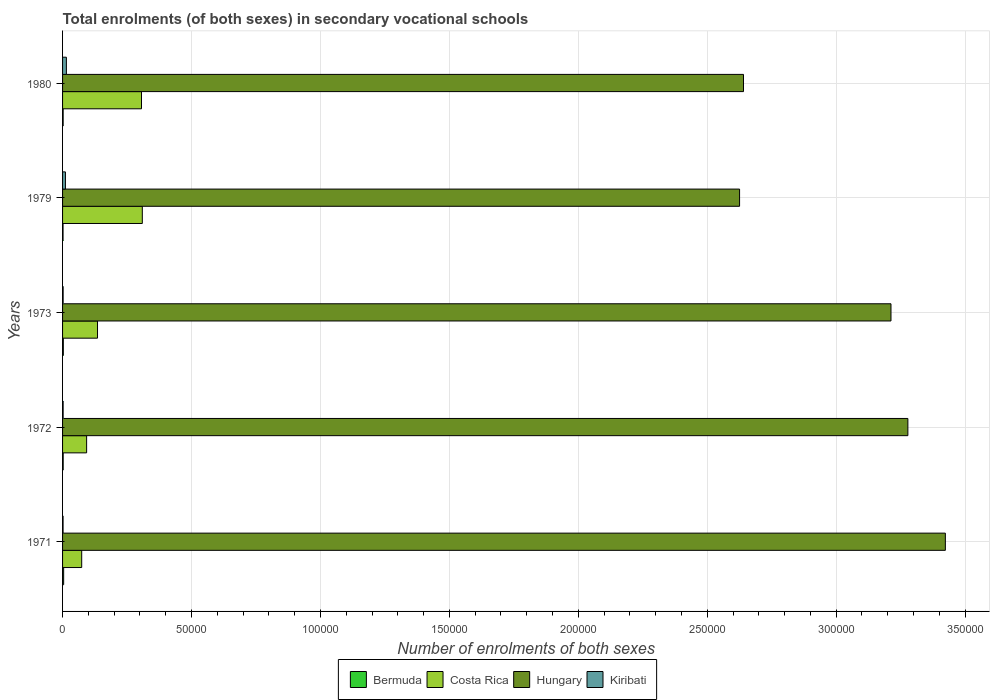Are the number of bars per tick equal to the number of legend labels?
Make the answer very short. Yes. How many bars are there on the 1st tick from the top?
Offer a very short reply. 4. What is the label of the 4th group of bars from the top?
Provide a succinct answer. 1972. What is the number of enrolments in secondary schools in Bermuda in 1979?
Provide a short and direct response. 184. Across all years, what is the maximum number of enrolments in secondary schools in Kiribati?
Provide a succinct answer. 1483. Across all years, what is the minimum number of enrolments in secondary schools in Costa Rica?
Offer a very short reply. 7424. In which year was the number of enrolments in secondary schools in Hungary minimum?
Provide a succinct answer. 1979. What is the total number of enrolments in secondary schools in Kiribati in the graph?
Ensure brevity in your answer.  3242. What is the difference between the number of enrolments in secondary schools in Bermuda in 1971 and that in 1979?
Provide a succinct answer. 240. What is the difference between the number of enrolments in secondary schools in Hungary in 1971 and the number of enrolments in secondary schools in Bermuda in 1980?
Your answer should be very brief. 3.42e+05. What is the average number of enrolments in secondary schools in Hungary per year?
Make the answer very short. 3.04e+05. In the year 1980, what is the difference between the number of enrolments in secondary schools in Kiribati and number of enrolments in secondary schools in Bermuda?
Your answer should be compact. 1256. In how many years, is the number of enrolments in secondary schools in Costa Rica greater than 150000 ?
Offer a terse response. 0. What is the ratio of the number of enrolments in secondary schools in Costa Rica in 1971 to that in 1980?
Offer a very short reply. 0.24. Is the number of enrolments in secondary schools in Bermuda in 1972 less than that in 1979?
Provide a short and direct response. No. Is the difference between the number of enrolments in secondary schools in Kiribati in 1971 and 1980 greater than the difference between the number of enrolments in secondary schools in Bermuda in 1971 and 1980?
Provide a succinct answer. No. What is the difference between the highest and the second highest number of enrolments in secondary schools in Costa Rica?
Provide a short and direct response. 313. What is the difference between the highest and the lowest number of enrolments in secondary schools in Hungary?
Provide a succinct answer. 7.98e+04. Is the sum of the number of enrolments in secondary schools in Kiribati in 1973 and 1980 greater than the maximum number of enrolments in secondary schools in Hungary across all years?
Your answer should be very brief. No. Is it the case that in every year, the sum of the number of enrolments in secondary schools in Hungary and number of enrolments in secondary schools in Kiribati is greater than the sum of number of enrolments in secondary schools in Costa Rica and number of enrolments in secondary schools in Bermuda?
Your response must be concise. Yes. What does the 1st bar from the top in 1971 represents?
Offer a terse response. Kiribati. What does the 4th bar from the bottom in 1980 represents?
Ensure brevity in your answer.  Kiribati. Are all the bars in the graph horizontal?
Ensure brevity in your answer.  Yes. What is the difference between two consecutive major ticks on the X-axis?
Your answer should be compact. 5.00e+04. Are the values on the major ticks of X-axis written in scientific E-notation?
Provide a succinct answer. No. Does the graph contain any zero values?
Ensure brevity in your answer.  No. Does the graph contain grids?
Keep it short and to the point. Yes. How many legend labels are there?
Offer a terse response. 4. How are the legend labels stacked?
Provide a short and direct response. Horizontal. What is the title of the graph?
Your answer should be compact. Total enrolments (of both sexes) in secondary vocational schools. Does "Korea (Republic)" appear as one of the legend labels in the graph?
Provide a short and direct response. No. What is the label or title of the X-axis?
Keep it short and to the point. Number of enrolments of both sexes. What is the Number of enrolments of both sexes of Bermuda in 1971?
Give a very brief answer. 424. What is the Number of enrolments of both sexes in Costa Rica in 1971?
Provide a short and direct response. 7424. What is the Number of enrolments of both sexes in Hungary in 1971?
Make the answer very short. 3.42e+05. What is the Number of enrolments of both sexes in Kiribati in 1971?
Give a very brief answer. 199. What is the Number of enrolments of both sexes of Bermuda in 1972?
Keep it short and to the point. 241. What is the Number of enrolments of both sexes of Costa Rica in 1972?
Your response must be concise. 9329. What is the Number of enrolments of both sexes of Hungary in 1972?
Your answer should be very brief. 3.28e+05. What is the Number of enrolments of both sexes of Kiribati in 1972?
Offer a very short reply. 222. What is the Number of enrolments of both sexes of Bermuda in 1973?
Offer a very short reply. 293. What is the Number of enrolments of both sexes in Costa Rica in 1973?
Your answer should be very brief. 1.36e+04. What is the Number of enrolments of both sexes of Hungary in 1973?
Keep it short and to the point. 3.21e+05. What is the Number of enrolments of both sexes in Kiribati in 1973?
Offer a terse response. 223. What is the Number of enrolments of both sexes in Bermuda in 1979?
Make the answer very short. 184. What is the Number of enrolments of both sexes of Costa Rica in 1979?
Offer a terse response. 3.09e+04. What is the Number of enrolments of both sexes of Hungary in 1979?
Offer a very short reply. 2.63e+05. What is the Number of enrolments of both sexes of Kiribati in 1979?
Make the answer very short. 1115. What is the Number of enrolments of both sexes of Bermuda in 1980?
Make the answer very short. 227. What is the Number of enrolments of both sexes in Costa Rica in 1980?
Offer a terse response. 3.06e+04. What is the Number of enrolments of both sexes of Hungary in 1980?
Provide a succinct answer. 2.64e+05. What is the Number of enrolments of both sexes of Kiribati in 1980?
Offer a very short reply. 1483. Across all years, what is the maximum Number of enrolments of both sexes in Bermuda?
Ensure brevity in your answer.  424. Across all years, what is the maximum Number of enrolments of both sexes in Costa Rica?
Make the answer very short. 3.09e+04. Across all years, what is the maximum Number of enrolments of both sexes in Hungary?
Give a very brief answer. 3.42e+05. Across all years, what is the maximum Number of enrolments of both sexes of Kiribati?
Your answer should be compact. 1483. Across all years, what is the minimum Number of enrolments of both sexes of Bermuda?
Your answer should be very brief. 184. Across all years, what is the minimum Number of enrolments of both sexes of Costa Rica?
Keep it short and to the point. 7424. Across all years, what is the minimum Number of enrolments of both sexes of Hungary?
Provide a succinct answer. 2.63e+05. Across all years, what is the minimum Number of enrolments of both sexes in Kiribati?
Your response must be concise. 199. What is the total Number of enrolments of both sexes in Bermuda in the graph?
Your answer should be very brief. 1369. What is the total Number of enrolments of both sexes of Costa Rica in the graph?
Give a very brief answer. 9.18e+04. What is the total Number of enrolments of both sexes of Hungary in the graph?
Keep it short and to the point. 1.52e+06. What is the total Number of enrolments of both sexes of Kiribati in the graph?
Your answer should be compact. 3242. What is the difference between the Number of enrolments of both sexes of Bermuda in 1971 and that in 1972?
Provide a short and direct response. 183. What is the difference between the Number of enrolments of both sexes of Costa Rica in 1971 and that in 1972?
Your answer should be compact. -1905. What is the difference between the Number of enrolments of both sexes of Hungary in 1971 and that in 1972?
Make the answer very short. 1.45e+04. What is the difference between the Number of enrolments of both sexes in Bermuda in 1971 and that in 1973?
Make the answer very short. 131. What is the difference between the Number of enrolments of both sexes of Costa Rica in 1971 and that in 1973?
Ensure brevity in your answer.  -6128. What is the difference between the Number of enrolments of both sexes of Hungary in 1971 and that in 1973?
Ensure brevity in your answer.  2.11e+04. What is the difference between the Number of enrolments of both sexes in Kiribati in 1971 and that in 1973?
Offer a very short reply. -24. What is the difference between the Number of enrolments of both sexes of Bermuda in 1971 and that in 1979?
Your answer should be very brief. 240. What is the difference between the Number of enrolments of both sexes of Costa Rica in 1971 and that in 1979?
Make the answer very short. -2.35e+04. What is the difference between the Number of enrolments of both sexes of Hungary in 1971 and that in 1979?
Keep it short and to the point. 7.98e+04. What is the difference between the Number of enrolments of both sexes in Kiribati in 1971 and that in 1979?
Make the answer very short. -916. What is the difference between the Number of enrolments of both sexes in Bermuda in 1971 and that in 1980?
Ensure brevity in your answer.  197. What is the difference between the Number of enrolments of both sexes in Costa Rica in 1971 and that in 1980?
Give a very brief answer. -2.32e+04. What is the difference between the Number of enrolments of both sexes of Hungary in 1971 and that in 1980?
Offer a terse response. 7.83e+04. What is the difference between the Number of enrolments of both sexes in Kiribati in 1971 and that in 1980?
Make the answer very short. -1284. What is the difference between the Number of enrolments of both sexes of Bermuda in 1972 and that in 1973?
Provide a succinct answer. -52. What is the difference between the Number of enrolments of both sexes in Costa Rica in 1972 and that in 1973?
Offer a terse response. -4223. What is the difference between the Number of enrolments of both sexes in Hungary in 1972 and that in 1973?
Your response must be concise. 6551. What is the difference between the Number of enrolments of both sexes of Costa Rica in 1972 and that in 1979?
Give a very brief answer. -2.16e+04. What is the difference between the Number of enrolments of both sexes in Hungary in 1972 and that in 1979?
Provide a short and direct response. 6.53e+04. What is the difference between the Number of enrolments of both sexes of Kiribati in 1972 and that in 1979?
Your answer should be compact. -893. What is the difference between the Number of enrolments of both sexes in Bermuda in 1972 and that in 1980?
Make the answer very short. 14. What is the difference between the Number of enrolments of both sexes of Costa Rica in 1972 and that in 1980?
Give a very brief answer. -2.13e+04. What is the difference between the Number of enrolments of both sexes of Hungary in 1972 and that in 1980?
Provide a succinct answer. 6.37e+04. What is the difference between the Number of enrolments of both sexes of Kiribati in 1972 and that in 1980?
Offer a terse response. -1261. What is the difference between the Number of enrolments of both sexes in Bermuda in 1973 and that in 1979?
Provide a succinct answer. 109. What is the difference between the Number of enrolments of both sexes in Costa Rica in 1973 and that in 1979?
Make the answer very short. -1.74e+04. What is the difference between the Number of enrolments of both sexes in Hungary in 1973 and that in 1979?
Provide a succinct answer. 5.87e+04. What is the difference between the Number of enrolments of both sexes in Kiribati in 1973 and that in 1979?
Offer a very short reply. -892. What is the difference between the Number of enrolments of both sexes of Costa Rica in 1973 and that in 1980?
Offer a very short reply. -1.71e+04. What is the difference between the Number of enrolments of both sexes in Hungary in 1973 and that in 1980?
Keep it short and to the point. 5.72e+04. What is the difference between the Number of enrolments of both sexes in Kiribati in 1973 and that in 1980?
Give a very brief answer. -1260. What is the difference between the Number of enrolments of both sexes in Bermuda in 1979 and that in 1980?
Offer a very short reply. -43. What is the difference between the Number of enrolments of both sexes of Costa Rica in 1979 and that in 1980?
Offer a terse response. 313. What is the difference between the Number of enrolments of both sexes in Hungary in 1979 and that in 1980?
Offer a very short reply. -1522. What is the difference between the Number of enrolments of both sexes of Kiribati in 1979 and that in 1980?
Your answer should be compact. -368. What is the difference between the Number of enrolments of both sexes of Bermuda in 1971 and the Number of enrolments of both sexes of Costa Rica in 1972?
Provide a succinct answer. -8905. What is the difference between the Number of enrolments of both sexes of Bermuda in 1971 and the Number of enrolments of both sexes of Hungary in 1972?
Your response must be concise. -3.27e+05. What is the difference between the Number of enrolments of both sexes of Bermuda in 1971 and the Number of enrolments of both sexes of Kiribati in 1972?
Ensure brevity in your answer.  202. What is the difference between the Number of enrolments of both sexes in Costa Rica in 1971 and the Number of enrolments of both sexes in Hungary in 1972?
Your answer should be compact. -3.20e+05. What is the difference between the Number of enrolments of both sexes of Costa Rica in 1971 and the Number of enrolments of both sexes of Kiribati in 1972?
Provide a succinct answer. 7202. What is the difference between the Number of enrolments of both sexes of Hungary in 1971 and the Number of enrolments of both sexes of Kiribati in 1972?
Give a very brief answer. 3.42e+05. What is the difference between the Number of enrolments of both sexes of Bermuda in 1971 and the Number of enrolments of both sexes of Costa Rica in 1973?
Provide a short and direct response. -1.31e+04. What is the difference between the Number of enrolments of both sexes in Bermuda in 1971 and the Number of enrolments of both sexes in Hungary in 1973?
Ensure brevity in your answer.  -3.21e+05. What is the difference between the Number of enrolments of both sexes of Bermuda in 1971 and the Number of enrolments of both sexes of Kiribati in 1973?
Your answer should be very brief. 201. What is the difference between the Number of enrolments of both sexes in Costa Rica in 1971 and the Number of enrolments of both sexes in Hungary in 1973?
Offer a terse response. -3.14e+05. What is the difference between the Number of enrolments of both sexes of Costa Rica in 1971 and the Number of enrolments of both sexes of Kiribati in 1973?
Your answer should be compact. 7201. What is the difference between the Number of enrolments of both sexes of Hungary in 1971 and the Number of enrolments of both sexes of Kiribati in 1973?
Provide a succinct answer. 3.42e+05. What is the difference between the Number of enrolments of both sexes of Bermuda in 1971 and the Number of enrolments of both sexes of Costa Rica in 1979?
Give a very brief answer. -3.05e+04. What is the difference between the Number of enrolments of both sexes of Bermuda in 1971 and the Number of enrolments of both sexes of Hungary in 1979?
Make the answer very short. -2.62e+05. What is the difference between the Number of enrolments of both sexes in Bermuda in 1971 and the Number of enrolments of both sexes in Kiribati in 1979?
Provide a succinct answer. -691. What is the difference between the Number of enrolments of both sexes of Costa Rica in 1971 and the Number of enrolments of both sexes of Hungary in 1979?
Offer a terse response. -2.55e+05. What is the difference between the Number of enrolments of both sexes of Costa Rica in 1971 and the Number of enrolments of both sexes of Kiribati in 1979?
Give a very brief answer. 6309. What is the difference between the Number of enrolments of both sexes of Hungary in 1971 and the Number of enrolments of both sexes of Kiribati in 1979?
Your answer should be very brief. 3.41e+05. What is the difference between the Number of enrolments of both sexes of Bermuda in 1971 and the Number of enrolments of both sexes of Costa Rica in 1980?
Provide a short and direct response. -3.02e+04. What is the difference between the Number of enrolments of both sexes in Bermuda in 1971 and the Number of enrolments of both sexes in Hungary in 1980?
Give a very brief answer. -2.64e+05. What is the difference between the Number of enrolments of both sexes of Bermuda in 1971 and the Number of enrolments of both sexes of Kiribati in 1980?
Provide a short and direct response. -1059. What is the difference between the Number of enrolments of both sexes of Costa Rica in 1971 and the Number of enrolments of both sexes of Hungary in 1980?
Your response must be concise. -2.57e+05. What is the difference between the Number of enrolments of both sexes of Costa Rica in 1971 and the Number of enrolments of both sexes of Kiribati in 1980?
Give a very brief answer. 5941. What is the difference between the Number of enrolments of both sexes in Hungary in 1971 and the Number of enrolments of both sexes in Kiribati in 1980?
Provide a short and direct response. 3.41e+05. What is the difference between the Number of enrolments of both sexes in Bermuda in 1972 and the Number of enrolments of both sexes in Costa Rica in 1973?
Give a very brief answer. -1.33e+04. What is the difference between the Number of enrolments of both sexes of Bermuda in 1972 and the Number of enrolments of both sexes of Hungary in 1973?
Keep it short and to the point. -3.21e+05. What is the difference between the Number of enrolments of both sexes of Costa Rica in 1972 and the Number of enrolments of both sexes of Hungary in 1973?
Provide a succinct answer. -3.12e+05. What is the difference between the Number of enrolments of both sexes in Costa Rica in 1972 and the Number of enrolments of both sexes in Kiribati in 1973?
Keep it short and to the point. 9106. What is the difference between the Number of enrolments of both sexes in Hungary in 1972 and the Number of enrolments of both sexes in Kiribati in 1973?
Provide a succinct answer. 3.28e+05. What is the difference between the Number of enrolments of both sexes in Bermuda in 1972 and the Number of enrolments of both sexes in Costa Rica in 1979?
Provide a succinct answer. -3.07e+04. What is the difference between the Number of enrolments of both sexes in Bermuda in 1972 and the Number of enrolments of both sexes in Hungary in 1979?
Provide a succinct answer. -2.62e+05. What is the difference between the Number of enrolments of both sexes of Bermuda in 1972 and the Number of enrolments of both sexes of Kiribati in 1979?
Offer a very short reply. -874. What is the difference between the Number of enrolments of both sexes in Costa Rica in 1972 and the Number of enrolments of both sexes in Hungary in 1979?
Your answer should be compact. -2.53e+05. What is the difference between the Number of enrolments of both sexes of Costa Rica in 1972 and the Number of enrolments of both sexes of Kiribati in 1979?
Provide a short and direct response. 8214. What is the difference between the Number of enrolments of both sexes in Hungary in 1972 and the Number of enrolments of both sexes in Kiribati in 1979?
Keep it short and to the point. 3.27e+05. What is the difference between the Number of enrolments of both sexes in Bermuda in 1972 and the Number of enrolments of both sexes in Costa Rica in 1980?
Offer a very short reply. -3.04e+04. What is the difference between the Number of enrolments of both sexes of Bermuda in 1972 and the Number of enrolments of both sexes of Hungary in 1980?
Provide a short and direct response. -2.64e+05. What is the difference between the Number of enrolments of both sexes in Bermuda in 1972 and the Number of enrolments of both sexes in Kiribati in 1980?
Make the answer very short. -1242. What is the difference between the Number of enrolments of both sexes in Costa Rica in 1972 and the Number of enrolments of both sexes in Hungary in 1980?
Offer a very short reply. -2.55e+05. What is the difference between the Number of enrolments of both sexes in Costa Rica in 1972 and the Number of enrolments of both sexes in Kiribati in 1980?
Ensure brevity in your answer.  7846. What is the difference between the Number of enrolments of both sexes in Hungary in 1972 and the Number of enrolments of both sexes in Kiribati in 1980?
Give a very brief answer. 3.26e+05. What is the difference between the Number of enrolments of both sexes of Bermuda in 1973 and the Number of enrolments of both sexes of Costa Rica in 1979?
Offer a very short reply. -3.06e+04. What is the difference between the Number of enrolments of both sexes in Bermuda in 1973 and the Number of enrolments of both sexes in Hungary in 1979?
Your answer should be compact. -2.62e+05. What is the difference between the Number of enrolments of both sexes in Bermuda in 1973 and the Number of enrolments of both sexes in Kiribati in 1979?
Give a very brief answer. -822. What is the difference between the Number of enrolments of both sexes of Costa Rica in 1973 and the Number of enrolments of both sexes of Hungary in 1979?
Ensure brevity in your answer.  -2.49e+05. What is the difference between the Number of enrolments of both sexes in Costa Rica in 1973 and the Number of enrolments of both sexes in Kiribati in 1979?
Give a very brief answer. 1.24e+04. What is the difference between the Number of enrolments of both sexes of Hungary in 1973 and the Number of enrolments of both sexes of Kiribati in 1979?
Keep it short and to the point. 3.20e+05. What is the difference between the Number of enrolments of both sexes in Bermuda in 1973 and the Number of enrolments of both sexes in Costa Rica in 1980?
Your answer should be very brief. -3.03e+04. What is the difference between the Number of enrolments of both sexes in Bermuda in 1973 and the Number of enrolments of both sexes in Hungary in 1980?
Provide a short and direct response. -2.64e+05. What is the difference between the Number of enrolments of both sexes of Bermuda in 1973 and the Number of enrolments of both sexes of Kiribati in 1980?
Provide a succinct answer. -1190. What is the difference between the Number of enrolments of both sexes in Costa Rica in 1973 and the Number of enrolments of both sexes in Hungary in 1980?
Keep it short and to the point. -2.51e+05. What is the difference between the Number of enrolments of both sexes of Costa Rica in 1973 and the Number of enrolments of both sexes of Kiribati in 1980?
Offer a very short reply. 1.21e+04. What is the difference between the Number of enrolments of both sexes of Hungary in 1973 and the Number of enrolments of both sexes of Kiribati in 1980?
Provide a short and direct response. 3.20e+05. What is the difference between the Number of enrolments of both sexes in Bermuda in 1979 and the Number of enrolments of both sexes in Costa Rica in 1980?
Keep it short and to the point. -3.04e+04. What is the difference between the Number of enrolments of both sexes in Bermuda in 1979 and the Number of enrolments of both sexes in Hungary in 1980?
Make the answer very short. -2.64e+05. What is the difference between the Number of enrolments of both sexes of Bermuda in 1979 and the Number of enrolments of both sexes of Kiribati in 1980?
Offer a terse response. -1299. What is the difference between the Number of enrolments of both sexes of Costa Rica in 1979 and the Number of enrolments of both sexes of Hungary in 1980?
Provide a succinct answer. -2.33e+05. What is the difference between the Number of enrolments of both sexes in Costa Rica in 1979 and the Number of enrolments of both sexes in Kiribati in 1980?
Offer a terse response. 2.94e+04. What is the difference between the Number of enrolments of both sexes in Hungary in 1979 and the Number of enrolments of both sexes in Kiribati in 1980?
Offer a very short reply. 2.61e+05. What is the average Number of enrolments of both sexes of Bermuda per year?
Provide a succinct answer. 273.8. What is the average Number of enrolments of both sexes of Costa Rica per year?
Offer a terse response. 1.84e+04. What is the average Number of enrolments of both sexes in Hungary per year?
Your answer should be very brief. 3.04e+05. What is the average Number of enrolments of both sexes in Kiribati per year?
Your answer should be compact. 648.4. In the year 1971, what is the difference between the Number of enrolments of both sexes of Bermuda and Number of enrolments of both sexes of Costa Rica?
Ensure brevity in your answer.  -7000. In the year 1971, what is the difference between the Number of enrolments of both sexes of Bermuda and Number of enrolments of both sexes of Hungary?
Keep it short and to the point. -3.42e+05. In the year 1971, what is the difference between the Number of enrolments of both sexes in Bermuda and Number of enrolments of both sexes in Kiribati?
Your answer should be compact. 225. In the year 1971, what is the difference between the Number of enrolments of both sexes in Costa Rica and Number of enrolments of both sexes in Hungary?
Offer a terse response. -3.35e+05. In the year 1971, what is the difference between the Number of enrolments of both sexes in Costa Rica and Number of enrolments of both sexes in Kiribati?
Your answer should be very brief. 7225. In the year 1971, what is the difference between the Number of enrolments of both sexes in Hungary and Number of enrolments of both sexes in Kiribati?
Provide a short and direct response. 3.42e+05. In the year 1972, what is the difference between the Number of enrolments of both sexes of Bermuda and Number of enrolments of both sexes of Costa Rica?
Offer a very short reply. -9088. In the year 1972, what is the difference between the Number of enrolments of both sexes of Bermuda and Number of enrolments of both sexes of Hungary?
Ensure brevity in your answer.  -3.28e+05. In the year 1972, what is the difference between the Number of enrolments of both sexes of Bermuda and Number of enrolments of both sexes of Kiribati?
Ensure brevity in your answer.  19. In the year 1972, what is the difference between the Number of enrolments of both sexes in Costa Rica and Number of enrolments of both sexes in Hungary?
Your answer should be very brief. -3.18e+05. In the year 1972, what is the difference between the Number of enrolments of both sexes of Costa Rica and Number of enrolments of both sexes of Kiribati?
Offer a terse response. 9107. In the year 1972, what is the difference between the Number of enrolments of both sexes of Hungary and Number of enrolments of both sexes of Kiribati?
Offer a very short reply. 3.28e+05. In the year 1973, what is the difference between the Number of enrolments of both sexes of Bermuda and Number of enrolments of both sexes of Costa Rica?
Ensure brevity in your answer.  -1.33e+04. In the year 1973, what is the difference between the Number of enrolments of both sexes in Bermuda and Number of enrolments of both sexes in Hungary?
Your answer should be very brief. -3.21e+05. In the year 1973, what is the difference between the Number of enrolments of both sexes in Costa Rica and Number of enrolments of both sexes in Hungary?
Your answer should be very brief. -3.08e+05. In the year 1973, what is the difference between the Number of enrolments of both sexes in Costa Rica and Number of enrolments of both sexes in Kiribati?
Give a very brief answer. 1.33e+04. In the year 1973, what is the difference between the Number of enrolments of both sexes of Hungary and Number of enrolments of both sexes of Kiribati?
Keep it short and to the point. 3.21e+05. In the year 1979, what is the difference between the Number of enrolments of both sexes of Bermuda and Number of enrolments of both sexes of Costa Rica?
Your answer should be compact. -3.07e+04. In the year 1979, what is the difference between the Number of enrolments of both sexes in Bermuda and Number of enrolments of both sexes in Hungary?
Give a very brief answer. -2.62e+05. In the year 1979, what is the difference between the Number of enrolments of both sexes of Bermuda and Number of enrolments of both sexes of Kiribati?
Offer a very short reply. -931. In the year 1979, what is the difference between the Number of enrolments of both sexes of Costa Rica and Number of enrolments of both sexes of Hungary?
Offer a terse response. -2.32e+05. In the year 1979, what is the difference between the Number of enrolments of both sexes in Costa Rica and Number of enrolments of both sexes in Kiribati?
Make the answer very short. 2.98e+04. In the year 1979, what is the difference between the Number of enrolments of both sexes of Hungary and Number of enrolments of both sexes of Kiribati?
Your answer should be very brief. 2.61e+05. In the year 1980, what is the difference between the Number of enrolments of both sexes in Bermuda and Number of enrolments of both sexes in Costa Rica?
Offer a terse response. -3.04e+04. In the year 1980, what is the difference between the Number of enrolments of both sexes in Bermuda and Number of enrolments of both sexes in Hungary?
Offer a very short reply. -2.64e+05. In the year 1980, what is the difference between the Number of enrolments of both sexes of Bermuda and Number of enrolments of both sexes of Kiribati?
Give a very brief answer. -1256. In the year 1980, what is the difference between the Number of enrolments of both sexes of Costa Rica and Number of enrolments of both sexes of Hungary?
Offer a very short reply. -2.33e+05. In the year 1980, what is the difference between the Number of enrolments of both sexes in Costa Rica and Number of enrolments of both sexes in Kiribati?
Offer a very short reply. 2.91e+04. In the year 1980, what is the difference between the Number of enrolments of both sexes in Hungary and Number of enrolments of both sexes in Kiribati?
Offer a very short reply. 2.63e+05. What is the ratio of the Number of enrolments of both sexes in Bermuda in 1971 to that in 1972?
Give a very brief answer. 1.76. What is the ratio of the Number of enrolments of both sexes of Costa Rica in 1971 to that in 1972?
Keep it short and to the point. 0.8. What is the ratio of the Number of enrolments of both sexes in Hungary in 1971 to that in 1972?
Make the answer very short. 1.04. What is the ratio of the Number of enrolments of both sexes of Kiribati in 1971 to that in 1972?
Provide a short and direct response. 0.9. What is the ratio of the Number of enrolments of both sexes in Bermuda in 1971 to that in 1973?
Make the answer very short. 1.45. What is the ratio of the Number of enrolments of both sexes of Costa Rica in 1971 to that in 1973?
Ensure brevity in your answer.  0.55. What is the ratio of the Number of enrolments of both sexes in Hungary in 1971 to that in 1973?
Provide a succinct answer. 1.07. What is the ratio of the Number of enrolments of both sexes of Kiribati in 1971 to that in 1973?
Make the answer very short. 0.89. What is the ratio of the Number of enrolments of both sexes of Bermuda in 1971 to that in 1979?
Your answer should be compact. 2.3. What is the ratio of the Number of enrolments of both sexes in Costa Rica in 1971 to that in 1979?
Offer a very short reply. 0.24. What is the ratio of the Number of enrolments of both sexes of Hungary in 1971 to that in 1979?
Offer a terse response. 1.3. What is the ratio of the Number of enrolments of both sexes of Kiribati in 1971 to that in 1979?
Offer a terse response. 0.18. What is the ratio of the Number of enrolments of both sexes in Bermuda in 1971 to that in 1980?
Your answer should be compact. 1.87. What is the ratio of the Number of enrolments of both sexes in Costa Rica in 1971 to that in 1980?
Make the answer very short. 0.24. What is the ratio of the Number of enrolments of both sexes of Hungary in 1971 to that in 1980?
Provide a short and direct response. 1.3. What is the ratio of the Number of enrolments of both sexes in Kiribati in 1971 to that in 1980?
Provide a short and direct response. 0.13. What is the ratio of the Number of enrolments of both sexes in Bermuda in 1972 to that in 1973?
Offer a very short reply. 0.82. What is the ratio of the Number of enrolments of both sexes in Costa Rica in 1972 to that in 1973?
Offer a terse response. 0.69. What is the ratio of the Number of enrolments of both sexes in Hungary in 1972 to that in 1973?
Your response must be concise. 1.02. What is the ratio of the Number of enrolments of both sexes in Bermuda in 1972 to that in 1979?
Provide a short and direct response. 1.31. What is the ratio of the Number of enrolments of both sexes in Costa Rica in 1972 to that in 1979?
Provide a succinct answer. 0.3. What is the ratio of the Number of enrolments of both sexes of Hungary in 1972 to that in 1979?
Your response must be concise. 1.25. What is the ratio of the Number of enrolments of both sexes in Kiribati in 1972 to that in 1979?
Your response must be concise. 0.2. What is the ratio of the Number of enrolments of both sexes in Bermuda in 1972 to that in 1980?
Ensure brevity in your answer.  1.06. What is the ratio of the Number of enrolments of both sexes of Costa Rica in 1972 to that in 1980?
Give a very brief answer. 0.3. What is the ratio of the Number of enrolments of both sexes in Hungary in 1972 to that in 1980?
Make the answer very short. 1.24. What is the ratio of the Number of enrolments of both sexes in Kiribati in 1972 to that in 1980?
Provide a short and direct response. 0.15. What is the ratio of the Number of enrolments of both sexes of Bermuda in 1973 to that in 1979?
Offer a very short reply. 1.59. What is the ratio of the Number of enrolments of both sexes of Costa Rica in 1973 to that in 1979?
Your answer should be compact. 0.44. What is the ratio of the Number of enrolments of both sexes of Hungary in 1973 to that in 1979?
Give a very brief answer. 1.22. What is the ratio of the Number of enrolments of both sexes of Bermuda in 1973 to that in 1980?
Keep it short and to the point. 1.29. What is the ratio of the Number of enrolments of both sexes in Costa Rica in 1973 to that in 1980?
Offer a terse response. 0.44. What is the ratio of the Number of enrolments of both sexes of Hungary in 1973 to that in 1980?
Make the answer very short. 1.22. What is the ratio of the Number of enrolments of both sexes in Kiribati in 1973 to that in 1980?
Your answer should be very brief. 0.15. What is the ratio of the Number of enrolments of both sexes of Bermuda in 1979 to that in 1980?
Give a very brief answer. 0.81. What is the ratio of the Number of enrolments of both sexes of Costa Rica in 1979 to that in 1980?
Your answer should be compact. 1.01. What is the ratio of the Number of enrolments of both sexes of Hungary in 1979 to that in 1980?
Make the answer very short. 0.99. What is the ratio of the Number of enrolments of both sexes of Kiribati in 1979 to that in 1980?
Make the answer very short. 0.75. What is the difference between the highest and the second highest Number of enrolments of both sexes of Bermuda?
Keep it short and to the point. 131. What is the difference between the highest and the second highest Number of enrolments of both sexes of Costa Rica?
Keep it short and to the point. 313. What is the difference between the highest and the second highest Number of enrolments of both sexes of Hungary?
Give a very brief answer. 1.45e+04. What is the difference between the highest and the second highest Number of enrolments of both sexes of Kiribati?
Ensure brevity in your answer.  368. What is the difference between the highest and the lowest Number of enrolments of both sexes of Bermuda?
Your answer should be very brief. 240. What is the difference between the highest and the lowest Number of enrolments of both sexes in Costa Rica?
Offer a terse response. 2.35e+04. What is the difference between the highest and the lowest Number of enrolments of both sexes in Hungary?
Provide a short and direct response. 7.98e+04. What is the difference between the highest and the lowest Number of enrolments of both sexes of Kiribati?
Give a very brief answer. 1284. 